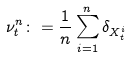<formula> <loc_0><loc_0><loc_500><loc_500>\nu _ { t } ^ { n } \colon = \frac { 1 } { n } \sum _ { i = 1 } ^ { n } \delta _ { X ^ { i } _ { t } }</formula> 